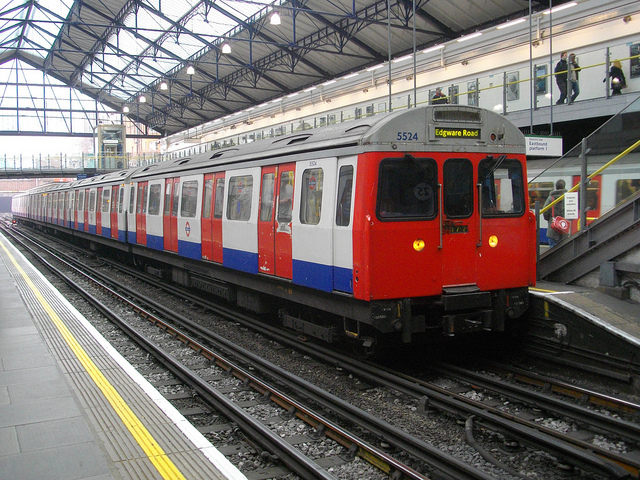Please transcribe the text information in this image. 5524 Edgware 